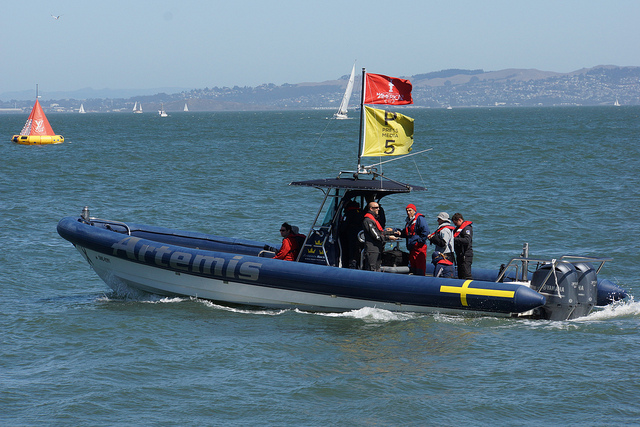Identify and read out the text in this image. Artemis 5 P 